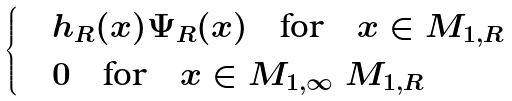Convert formula to latex. <formula><loc_0><loc_0><loc_500><loc_500>\begin{cases} & h _ { R } ( x ) \Psi _ { R } ( x ) \quad \text {for} \quad x \in M _ { 1 , R } \\ & 0 \quad \text {for} \quad x \in M _ { 1 , \infty } \ M _ { 1 , R } \end{cases}</formula> 